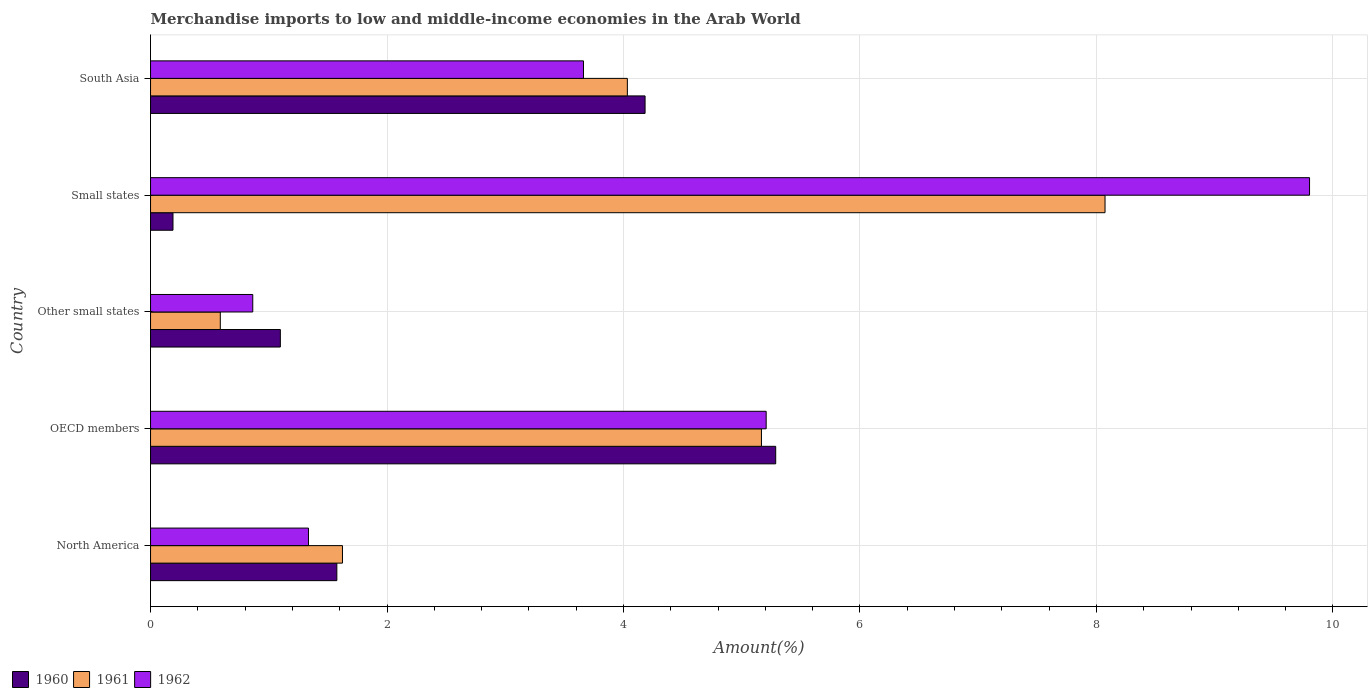How many different coloured bars are there?
Provide a succinct answer. 3. How many bars are there on the 3rd tick from the top?
Provide a succinct answer. 3. What is the label of the 2nd group of bars from the top?
Your answer should be compact. Small states. What is the percentage of amount earned from merchandise imports in 1960 in OECD members?
Provide a succinct answer. 5.29. Across all countries, what is the maximum percentage of amount earned from merchandise imports in 1962?
Provide a succinct answer. 9.8. Across all countries, what is the minimum percentage of amount earned from merchandise imports in 1960?
Keep it short and to the point. 0.19. In which country was the percentage of amount earned from merchandise imports in 1961 minimum?
Keep it short and to the point. Other small states. What is the total percentage of amount earned from merchandise imports in 1960 in the graph?
Give a very brief answer. 12.33. What is the difference between the percentage of amount earned from merchandise imports in 1962 in North America and that in Small states?
Make the answer very short. -8.47. What is the difference between the percentage of amount earned from merchandise imports in 1962 in North America and the percentage of amount earned from merchandise imports in 1961 in OECD members?
Provide a short and direct response. -3.83. What is the average percentage of amount earned from merchandise imports in 1960 per country?
Ensure brevity in your answer.  2.47. What is the difference between the percentage of amount earned from merchandise imports in 1960 and percentage of amount earned from merchandise imports in 1962 in Small states?
Your answer should be compact. -9.61. What is the ratio of the percentage of amount earned from merchandise imports in 1960 in North America to that in Small states?
Keep it short and to the point. 8.3. Is the difference between the percentage of amount earned from merchandise imports in 1960 in North America and South Asia greater than the difference between the percentage of amount earned from merchandise imports in 1962 in North America and South Asia?
Your response must be concise. No. What is the difference between the highest and the second highest percentage of amount earned from merchandise imports in 1961?
Offer a very short reply. 2.91. What is the difference between the highest and the lowest percentage of amount earned from merchandise imports in 1960?
Your answer should be very brief. 5.1. Is the sum of the percentage of amount earned from merchandise imports in 1960 in Other small states and Small states greater than the maximum percentage of amount earned from merchandise imports in 1961 across all countries?
Your answer should be compact. No. Is it the case that in every country, the sum of the percentage of amount earned from merchandise imports in 1961 and percentage of amount earned from merchandise imports in 1960 is greater than the percentage of amount earned from merchandise imports in 1962?
Keep it short and to the point. No. What is the difference between two consecutive major ticks on the X-axis?
Offer a terse response. 2. Are the values on the major ticks of X-axis written in scientific E-notation?
Provide a short and direct response. No. Does the graph contain any zero values?
Your response must be concise. No. How many legend labels are there?
Make the answer very short. 3. What is the title of the graph?
Give a very brief answer. Merchandise imports to low and middle-income economies in the Arab World. What is the label or title of the X-axis?
Provide a succinct answer. Amount(%). What is the Amount(%) in 1960 in North America?
Your answer should be compact. 1.58. What is the Amount(%) of 1961 in North America?
Offer a terse response. 1.62. What is the Amount(%) in 1962 in North America?
Provide a short and direct response. 1.34. What is the Amount(%) of 1960 in OECD members?
Provide a succinct answer. 5.29. What is the Amount(%) in 1961 in OECD members?
Your response must be concise. 5.17. What is the Amount(%) in 1962 in OECD members?
Provide a succinct answer. 5.21. What is the Amount(%) in 1960 in Other small states?
Make the answer very short. 1.1. What is the Amount(%) of 1961 in Other small states?
Provide a succinct answer. 0.59. What is the Amount(%) of 1962 in Other small states?
Ensure brevity in your answer.  0.86. What is the Amount(%) of 1960 in Small states?
Give a very brief answer. 0.19. What is the Amount(%) of 1961 in Small states?
Offer a very short reply. 8.07. What is the Amount(%) of 1962 in Small states?
Give a very brief answer. 9.8. What is the Amount(%) of 1960 in South Asia?
Your answer should be compact. 4.18. What is the Amount(%) of 1961 in South Asia?
Your response must be concise. 4.03. What is the Amount(%) in 1962 in South Asia?
Ensure brevity in your answer.  3.66. Across all countries, what is the maximum Amount(%) in 1960?
Keep it short and to the point. 5.29. Across all countries, what is the maximum Amount(%) in 1961?
Offer a terse response. 8.07. Across all countries, what is the maximum Amount(%) in 1962?
Your answer should be very brief. 9.8. Across all countries, what is the minimum Amount(%) of 1960?
Offer a terse response. 0.19. Across all countries, what is the minimum Amount(%) in 1961?
Give a very brief answer. 0.59. Across all countries, what is the minimum Amount(%) in 1962?
Keep it short and to the point. 0.86. What is the total Amount(%) of 1960 in the graph?
Your answer should be very brief. 12.33. What is the total Amount(%) in 1961 in the graph?
Make the answer very short. 19.48. What is the total Amount(%) of 1962 in the graph?
Provide a succinct answer. 20.87. What is the difference between the Amount(%) in 1960 in North America and that in OECD members?
Keep it short and to the point. -3.71. What is the difference between the Amount(%) of 1961 in North America and that in OECD members?
Provide a succinct answer. -3.54. What is the difference between the Amount(%) of 1962 in North America and that in OECD members?
Your response must be concise. -3.87. What is the difference between the Amount(%) of 1960 in North America and that in Other small states?
Make the answer very short. 0.48. What is the difference between the Amount(%) of 1962 in North America and that in Other small states?
Offer a very short reply. 0.47. What is the difference between the Amount(%) of 1960 in North America and that in Small states?
Provide a short and direct response. 1.39. What is the difference between the Amount(%) in 1961 in North America and that in Small states?
Your response must be concise. -6.45. What is the difference between the Amount(%) of 1962 in North America and that in Small states?
Keep it short and to the point. -8.47. What is the difference between the Amount(%) in 1960 in North America and that in South Asia?
Make the answer very short. -2.61. What is the difference between the Amount(%) in 1961 in North America and that in South Asia?
Make the answer very short. -2.41. What is the difference between the Amount(%) of 1962 in North America and that in South Asia?
Give a very brief answer. -2.33. What is the difference between the Amount(%) of 1960 in OECD members and that in Other small states?
Your answer should be very brief. 4.19. What is the difference between the Amount(%) of 1961 in OECD members and that in Other small states?
Ensure brevity in your answer.  4.58. What is the difference between the Amount(%) of 1962 in OECD members and that in Other small states?
Provide a succinct answer. 4.34. What is the difference between the Amount(%) of 1960 in OECD members and that in Small states?
Your answer should be very brief. 5.1. What is the difference between the Amount(%) of 1961 in OECD members and that in Small states?
Provide a succinct answer. -2.91. What is the difference between the Amount(%) in 1962 in OECD members and that in Small states?
Provide a short and direct response. -4.6. What is the difference between the Amount(%) in 1960 in OECD members and that in South Asia?
Make the answer very short. 1.1. What is the difference between the Amount(%) in 1961 in OECD members and that in South Asia?
Make the answer very short. 1.13. What is the difference between the Amount(%) of 1962 in OECD members and that in South Asia?
Provide a succinct answer. 1.54. What is the difference between the Amount(%) of 1960 in Other small states and that in Small states?
Give a very brief answer. 0.91. What is the difference between the Amount(%) in 1961 in Other small states and that in Small states?
Keep it short and to the point. -7.48. What is the difference between the Amount(%) of 1962 in Other small states and that in Small states?
Ensure brevity in your answer.  -8.94. What is the difference between the Amount(%) of 1960 in Other small states and that in South Asia?
Provide a short and direct response. -3.08. What is the difference between the Amount(%) of 1961 in Other small states and that in South Asia?
Provide a succinct answer. -3.44. What is the difference between the Amount(%) in 1962 in Other small states and that in South Asia?
Keep it short and to the point. -2.8. What is the difference between the Amount(%) of 1960 in Small states and that in South Asia?
Provide a short and direct response. -3.99. What is the difference between the Amount(%) of 1961 in Small states and that in South Asia?
Make the answer very short. 4.04. What is the difference between the Amount(%) in 1962 in Small states and that in South Asia?
Offer a terse response. 6.14. What is the difference between the Amount(%) of 1960 in North America and the Amount(%) of 1961 in OECD members?
Give a very brief answer. -3.59. What is the difference between the Amount(%) of 1960 in North America and the Amount(%) of 1962 in OECD members?
Keep it short and to the point. -3.63. What is the difference between the Amount(%) in 1961 in North America and the Amount(%) in 1962 in OECD members?
Ensure brevity in your answer.  -3.58. What is the difference between the Amount(%) in 1960 in North America and the Amount(%) in 1961 in Other small states?
Keep it short and to the point. 0.99. What is the difference between the Amount(%) in 1960 in North America and the Amount(%) in 1962 in Other small states?
Your response must be concise. 0.71. What is the difference between the Amount(%) in 1961 in North America and the Amount(%) in 1962 in Other small states?
Make the answer very short. 0.76. What is the difference between the Amount(%) of 1960 in North America and the Amount(%) of 1961 in Small states?
Ensure brevity in your answer.  -6.5. What is the difference between the Amount(%) of 1960 in North America and the Amount(%) of 1962 in Small states?
Offer a terse response. -8.23. What is the difference between the Amount(%) of 1961 in North America and the Amount(%) of 1962 in Small states?
Your answer should be compact. -8.18. What is the difference between the Amount(%) in 1960 in North America and the Amount(%) in 1961 in South Asia?
Give a very brief answer. -2.46. What is the difference between the Amount(%) of 1960 in North America and the Amount(%) of 1962 in South Asia?
Offer a terse response. -2.09. What is the difference between the Amount(%) in 1961 in North America and the Amount(%) in 1962 in South Asia?
Make the answer very short. -2.04. What is the difference between the Amount(%) in 1960 in OECD members and the Amount(%) in 1961 in Other small states?
Offer a very short reply. 4.7. What is the difference between the Amount(%) of 1960 in OECD members and the Amount(%) of 1962 in Other small states?
Make the answer very short. 4.42. What is the difference between the Amount(%) of 1961 in OECD members and the Amount(%) of 1962 in Other small states?
Provide a short and direct response. 4.3. What is the difference between the Amount(%) of 1960 in OECD members and the Amount(%) of 1961 in Small states?
Provide a short and direct response. -2.79. What is the difference between the Amount(%) in 1960 in OECD members and the Amount(%) in 1962 in Small states?
Your answer should be very brief. -4.51. What is the difference between the Amount(%) of 1961 in OECD members and the Amount(%) of 1962 in Small states?
Keep it short and to the point. -4.64. What is the difference between the Amount(%) in 1960 in OECD members and the Amount(%) in 1961 in South Asia?
Ensure brevity in your answer.  1.25. What is the difference between the Amount(%) of 1960 in OECD members and the Amount(%) of 1962 in South Asia?
Keep it short and to the point. 1.63. What is the difference between the Amount(%) in 1961 in OECD members and the Amount(%) in 1962 in South Asia?
Provide a short and direct response. 1.51. What is the difference between the Amount(%) in 1960 in Other small states and the Amount(%) in 1961 in Small states?
Your response must be concise. -6.97. What is the difference between the Amount(%) in 1960 in Other small states and the Amount(%) in 1962 in Small states?
Ensure brevity in your answer.  -8.7. What is the difference between the Amount(%) of 1961 in Other small states and the Amount(%) of 1962 in Small states?
Keep it short and to the point. -9.21. What is the difference between the Amount(%) of 1960 in Other small states and the Amount(%) of 1961 in South Asia?
Provide a succinct answer. -2.93. What is the difference between the Amount(%) of 1960 in Other small states and the Amount(%) of 1962 in South Asia?
Give a very brief answer. -2.56. What is the difference between the Amount(%) in 1961 in Other small states and the Amount(%) in 1962 in South Asia?
Your answer should be compact. -3.07. What is the difference between the Amount(%) in 1960 in Small states and the Amount(%) in 1961 in South Asia?
Your answer should be very brief. -3.84. What is the difference between the Amount(%) in 1960 in Small states and the Amount(%) in 1962 in South Asia?
Your answer should be very brief. -3.47. What is the difference between the Amount(%) of 1961 in Small states and the Amount(%) of 1962 in South Asia?
Give a very brief answer. 4.41. What is the average Amount(%) in 1960 per country?
Ensure brevity in your answer.  2.47. What is the average Amount(%) in 1961 per country?
Give a very brief answer. 3.9. What is the average Amount(%) in 1962 per country?
Your answer should be compact. 4.17. What is the difference between the Amount(%) in 1960 and Amount(%) in 1961 in North America?
Provide a short and direct response. -0.05. What is the difference between the Amount(%) of 1960 and Amount(%) of 1962 in North America?
Make the answer very short. 0.24. What is the difference between the Amount(%) in 1961 and Amount(%) in 1962 in North America?
Keep it short and to the point. 0.29. What is the difference between the Amount(%) in 1960 and Amount(%) in 1961 in OECD members?
Your response must be concise. 0.12. What is the difference between the Amount(%) in 1960 and Amount(%) in 1962 in OECD members?
Your answer should be compact. 0.08. What is the difference between the Amount(%) of 1961 and Amount(%) of 1962 in OECD members?
Provide a succinct answer. -0.04. What is the difference between the Amount(%) of 1960 and Amount(%) of 1961 in Other small states?
Offer a terse response. 0.51. What is the difference between the Amount(%) of 1960 and Amount(%) of 1962 in Other small states?
Ensure brevity in your answer.  0.23. What is the difference between the Amount(%) of 1961 and Amount(%) of 1962 in Other small states?
Offer a terse response. -0.27. What is the difference between the Amount(%) of 1960 and Amount(%) of 1961 in Small states?
Your answer should be compact. -7.88. What is the difference between the Amount(%) of 1960 and Amount(%) of 1962 in Small states?
Your answer should be very brief. -9.61. What is the difference between the Amount(%) of 1961 and Amount(%) of 1962 in Small states?
Ensure brevity in your answer.  -1.73. What is the difference between the Amount(%) in 1960 and Amount(%) in 1961 in South Asia?
Your answer should be very brief. 0.15. What is the difference between the Amount(%) of 1960 and Amount(%) of 1962 in South Asia?
Offer a terse response. 0.52. What is the difference between the Amount(%) of 1961 and Amount(%) of 1962 in South Asia?
Provide a short and direct response. 0.37. What is the ratio of the Amount(%) in 1960 in North America to that in OECD members?
Offer a terse response. 0.3. What is the ratio of the Amount(%) in 1961 in North America to that in OECD members?
Provide a succinct answer. 0.31. What is the ratio of the Amount(%) of 1962 in North America to that in OECD members?
Make the answer very short. 0.26. What is the ratio of the Amount(%) in 1960 in North America to that in Other small states?
Keep it short and to the point. 1.44. What is the ratio of the Amount(%) of 1961 in North America to that in Other small states?
Your answer should be compact. 2.75. What is the ratio of the Amount(%) in 1962 in North America to that in Other small states?
Provide a succinct answer. 1.54. What is the ratio of the Amount(%) in 1960 in North America to that in Small states?
Offer a very short reply. 8.3. What is the ratio of the Amount(%) in 1961 in North America to that in Small states?
Offer a very short reply. 0.2. What is the ratio of the Amount(%) in 1962 in North America to that in Small states?
Keep it short and to the point. 0.14. What is the ratio of the Amount(%) in 1960 in North America to that in South Asia?
Give a very brief answer. 0.38. What is the ratio of the Amount(%) in 1961 in North America to that in South Asia?
Offer a terse response. 0.4. What is the ratio of the Amount(%) of 1962 in North America to that in South Asia?
Give a very brief answer. 0.36. What is the ratio of the Amount(%) in 1960 in OECD members to that in Other small states?
Your answer should be very brief. 4.82. What is the ratio of the Amount(%) in 1961 in OECD members to that in Other small states?
Make the answer very short. 8.76. What is the ratio of the Amount(%) in 1962 in OECD members to that in Other small states?
Keep it short and to the point. 6.02. What is the ratio of the Amount(%) in 1960 in OECD members to that in Small states?
Your answer should be very brief. 27.86. What is the ratio of the Amount(%) in 1961 in OECD members to that in Small states?
Your answer should be very brief. 0.64. What is the ratio of the Amount(%) in 1962 in OECD members to that in Small states?
Keep it short and to the point. 0.53. What is the ratio of the Amount(%) in 1960 in OECD members to that in South Asia?
Your response must be concise. 1.26. What is the ratio of the Amount(%) of 1961 in OECD members to that in South Asia?
Ensure brevity in your answer.  1.28. What is the ratio of the Amount(%) in 1962 in OECD members to that in South Asia?
Offer a terse response. 1.42. What is the ratio of the Amount(%) of 1960 in Other small states to that in Small states?
Offer a very short reply. 5.78. What is the ratio of the Amount(%) of 1961 in Other small states to that in Small states?
Your response must be concise. 0.07. What is the ratio of the Amount(%) in 1962 in Other small states to that in Small states?
Keep it short and to the point. 0.09. What is the ratio of the Amount(%) of 1960 in Other small states to that in South Asia?
Offer a very short reply. 0.26. What is the ratio of the Amount(%) of 1961 in Other small states to that in South Asia?
Your answer should be very brief. 0.15. What is the ratio of the Amount(%) of 1962 in Other small states to that in South Asia?
Your answer should be compact. 0.24. What is the ratio of the Amount(%) of 1960 in Small states to that in South Asia?
Provide a succinct answer. 0.05. What is the ratio of the Amount(%) of 1961 in Small states to that in South Asia?
Offer a very short reply. 2. What is the ratio of the Amount(%) of 1962 in Small states to that in South Asia?
Offer a terse response. 2.68. What is the difference between the highest and the second highest Amount(%) of 1960?
Your answer should be compact. 1.1. What is the difference between the highest and the second highest Amount(%) in 1961?
Your answer should be very brief. 2.91. What is the difference between the highest and the second highest Amount(%) of 1962?
Provide a short and direct response. 4.6. What is the difference between the highest and the lowest Amount(%) in 1960?
Your answer should be compact. 5.1. What is the difference between the highest and the lowest Amount(%) of 1961?
Provide a succinct answer. 7.48. What is the difference between the highest and the lowest Amount(%) of 1962?
Offer a terse response. 8.94. 